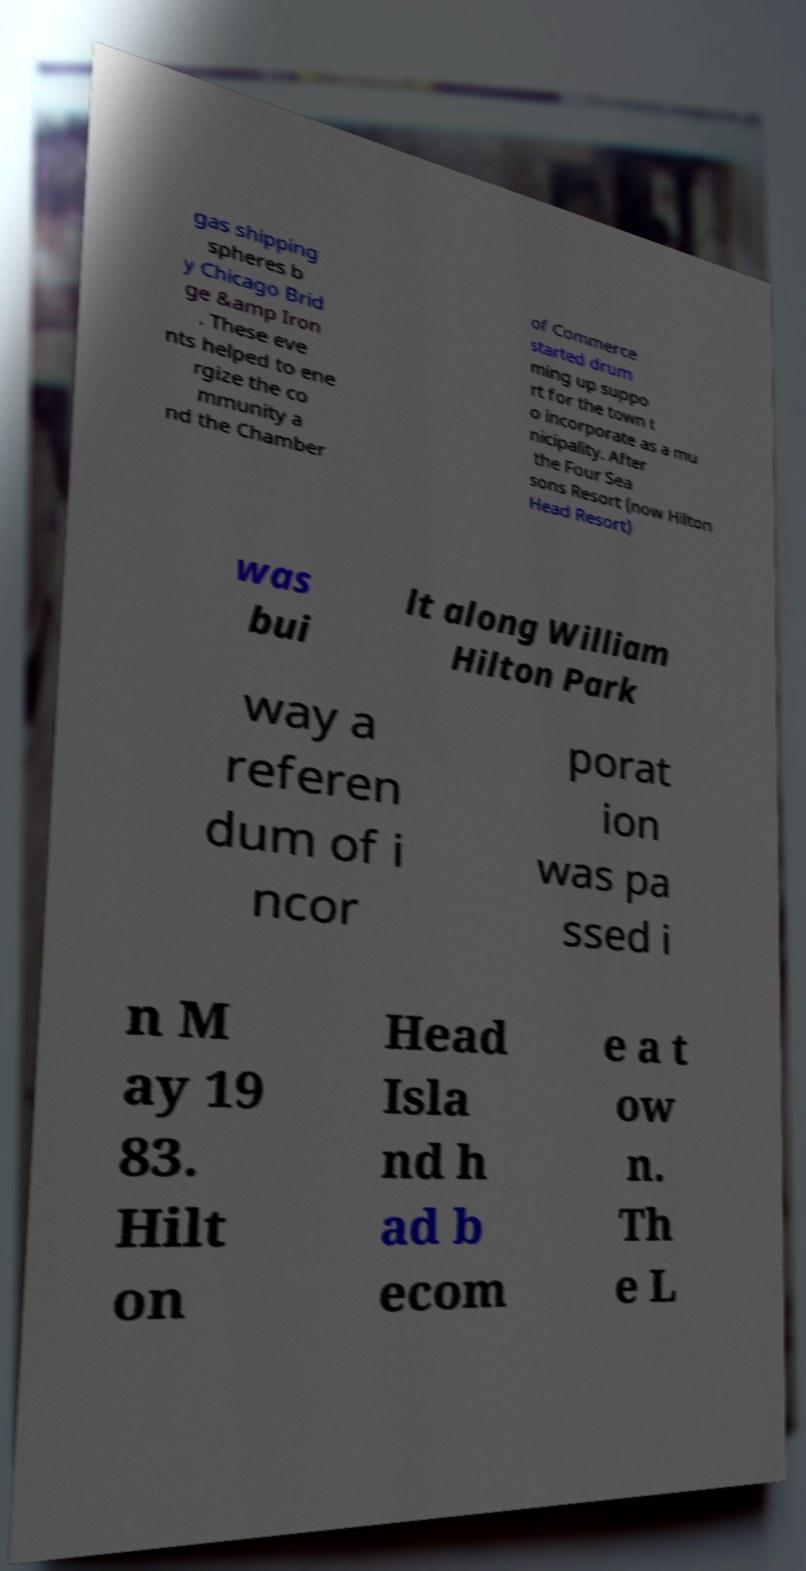Could you extract and type out the text from this image? gas shipping spheres b y Chicago Brid ge &amp Iron . These eve nts helped to ene rgize the co mmunity a nd the Chamber of Commerce started drum ming up suppo rt for the town t o incorporate as a mu nicipality. After the Four Sea sons Resort (now Hilton Head Resort) was bui lt along William Hilton Park way a referen dum of i ncor porat ion was pa ssed i n M ay 19 83. Hilt on Head Isla nd h ad b ecom e a t ow n. Th e L 